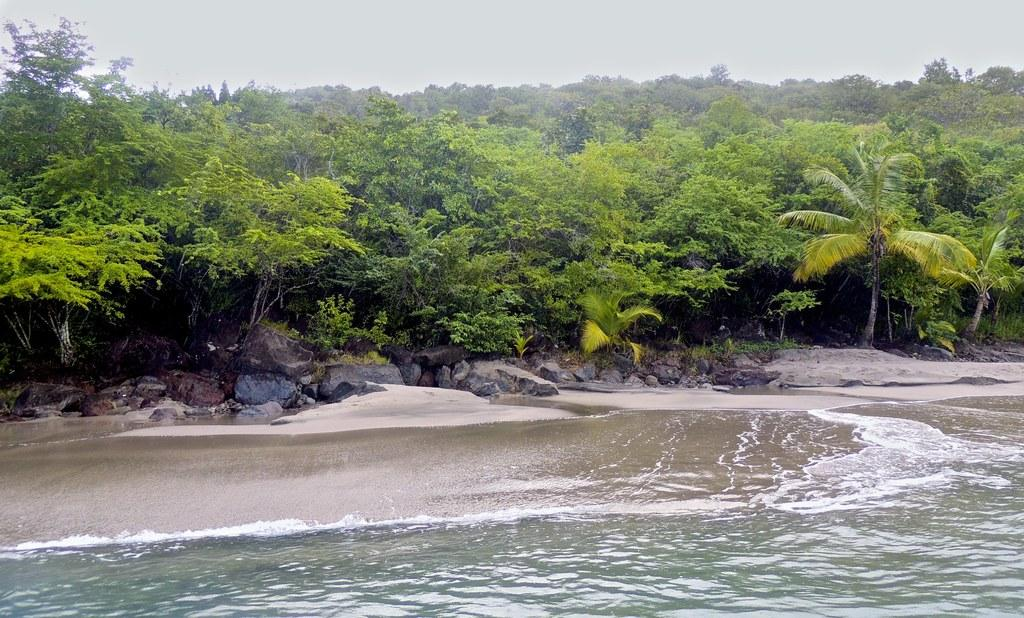What natural element can be seen in the image? Water is visible in the image. What type of objects are present in the image? There are stones in the image. What type of vegetation is visible in the image? There are trees in the image. What is visible in the background of the image? The sky is visible in the background of the image. How many babies are playing with the station in the image? There are no babies or stations present in the image. 